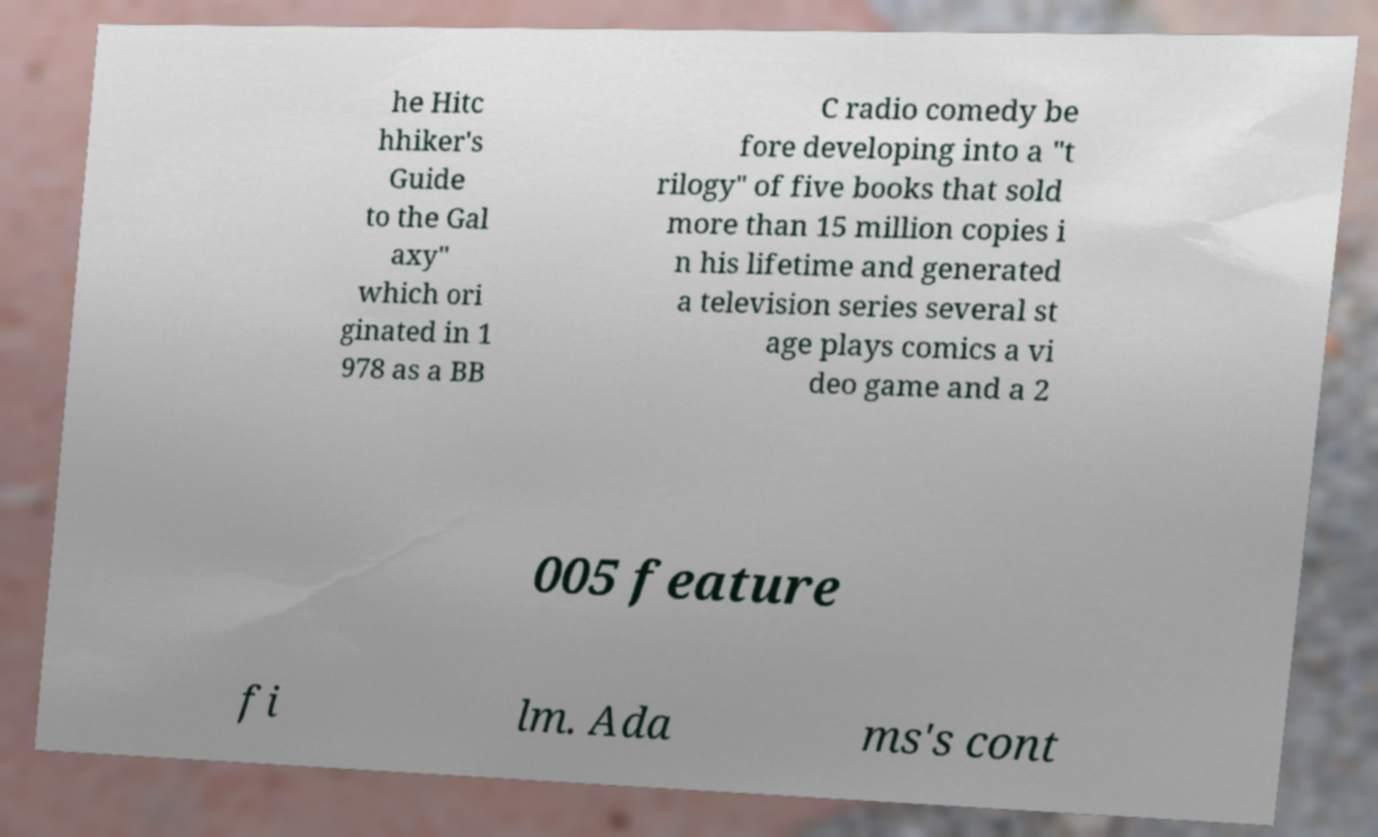There's text embedded in this image that I need extracted. Can you transcribe it verbatim? he Hitc hhiker's Guide to the Gal axy" which ori ginated in 1 978 as a BB C radio comedy be fore developing into a "t rilogy" of five books that sold more than 15 million copies i n his lifetime and generated a television series several st age plays comics a vi deo game and a 2 005 feature fi lm. Ada ms's cont 